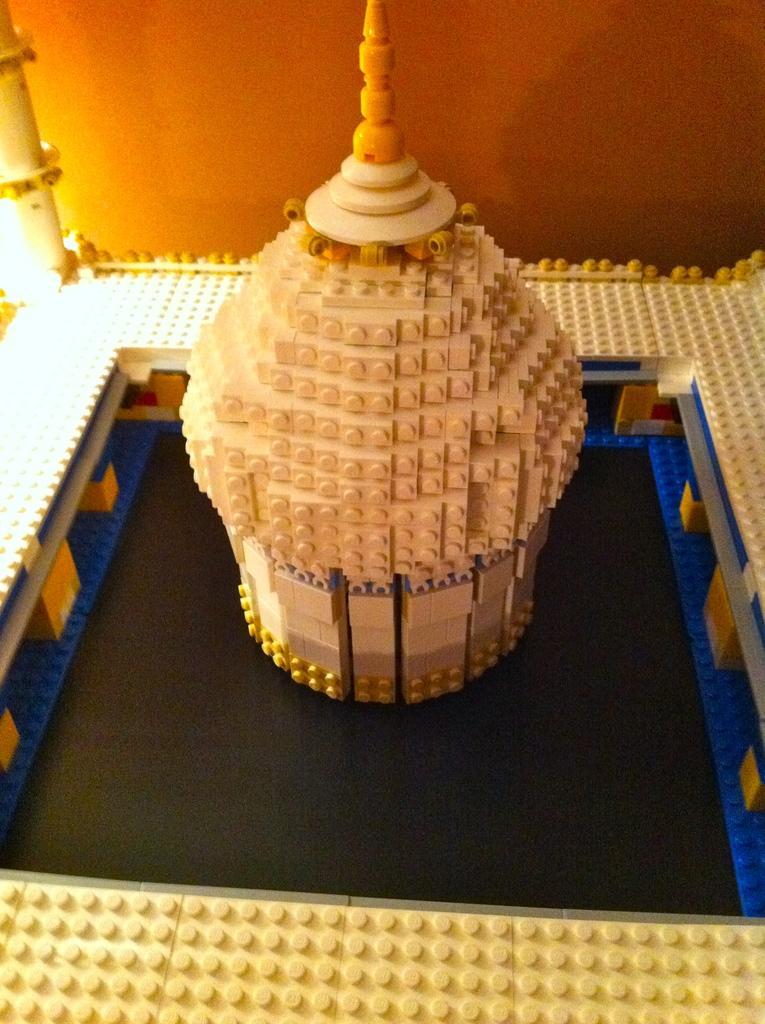Please provide a concise description of this image. In the picture I can see something looks like a building. In the background I can see a wall. 